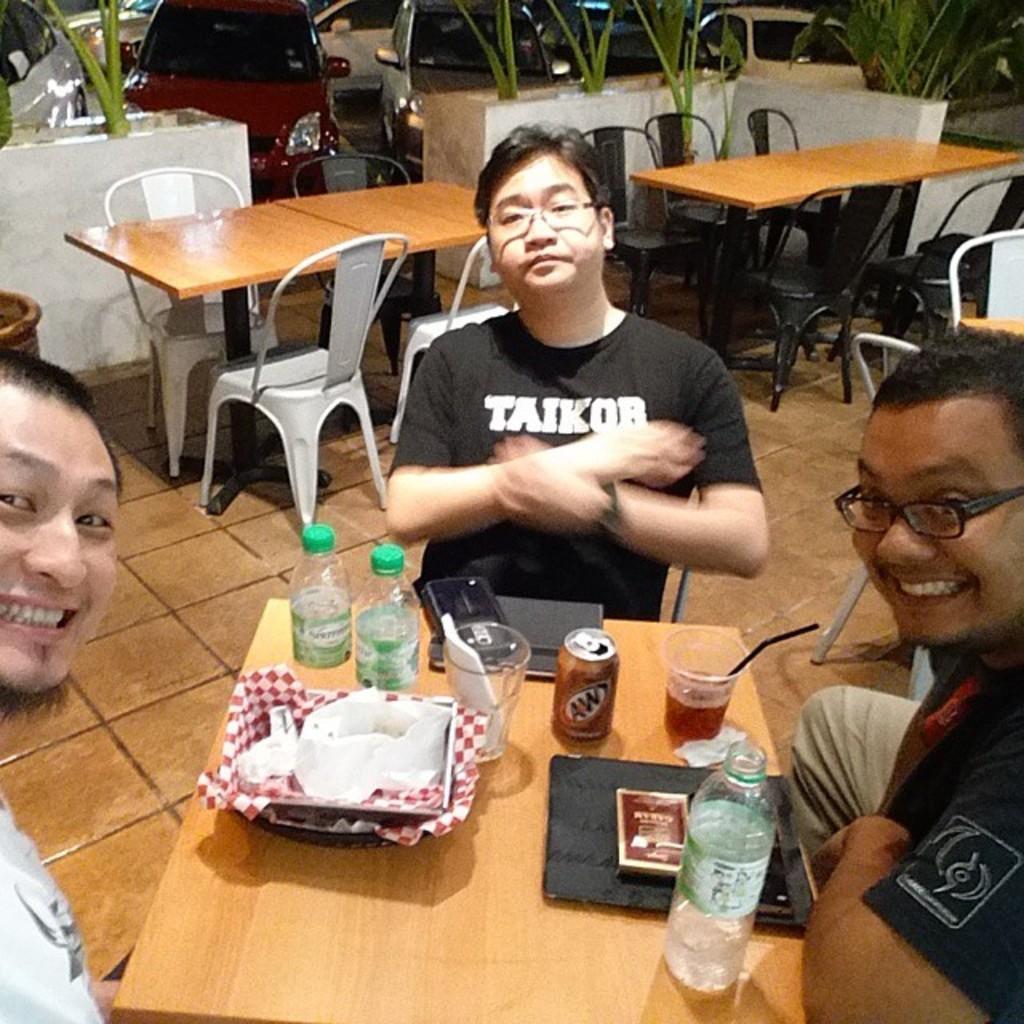Could you give a brief overview of what you see in this image? In this image we can see some group of persons sitting on chairs posing for a photograph there are some food items, glasses, water bottles on table and in the background of the image there are some tables, chairs, wall, plants and some vehicles which are parked. 